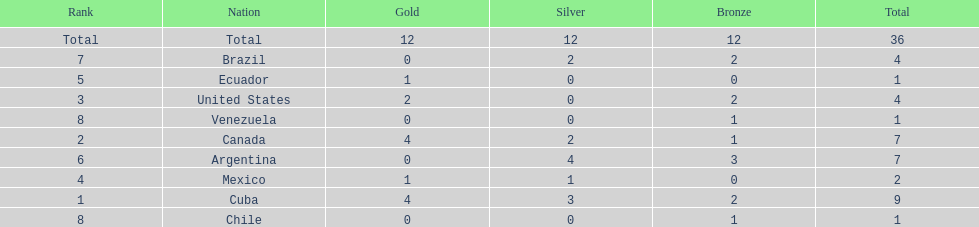Who is ranked #1? Cuba. Write the full table. {'header': ['Rank', 'Nation', 'Gold', 'Silver', 'Bronze', 'Total'], 'rows': [['Total', 'Total', '12', '12', '12', '36'], ['7', 'Brazil', '0', '2', '2', '4'], ['5', 'Ecuador', '1', '0', '0', '1'], ['3', 'United States', '2', '0', '2', '4'], ['8', 'Venezuela', '0', '0', '1', '1'], ['2', 'Canada', '4', '2', '1', '7'], ['6', 'Argentina', '0', '4', '3', '7'], ['4', 'Mexico', '1', '1', '0', '2'], ['1', 'Cuba', '4', '3', '2', '9'], ['8', 'Chile', '0', '0', '1', '1']]} 